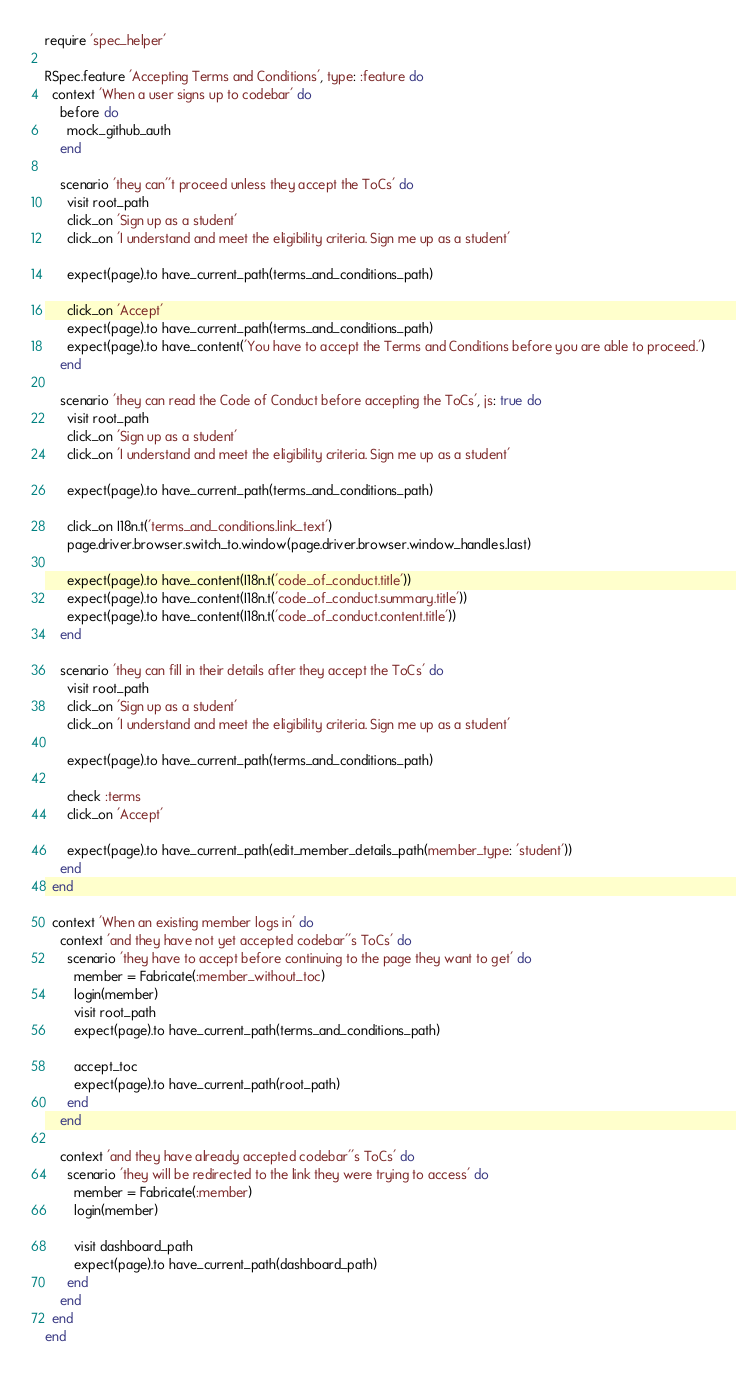Convert code to text. <code><loc_0><loc_0><loc_500><loc_500><_Ruby_>require 'spec_helper'

RSpec.feature 'Accepting Terms and Conditions', type: :feature do
  context 'When a user signs up to codebar' do
    before do
      mock_github_auth
    end

    scenario 'they can''t proceed unless they accept the ToCs' do
      visit root_path
      click_on 'Sign up as a student'
      click_on 'I understand and meet the eligibility criteria. Sign me up as a student'

      expect(page).to have_current_path(terms_and_conditions_path)

      click_on 'Accept'
      expect(page).to have_current_path(terms_and_conditions_path)
      expect(page).to have_content('You have to accept the Terms and Conditions before you are able to proceed.')
    end

    scenario 'they can read the Code of Conduct before accepting the ToCs', js: true do
      visit root_path
      click_on 'Sign up as a student'
      click_on 'I understand and meet the eligibility criteria. Sign me up as a student'

      expect(page).to have_current_path(terms_and_conditions_path)

      click_on I18n.t('terms_and_conditions.link_text')
      page.driver.browser.switch_to.window(page.driver.browser.window_handles.last)

      expect(page).to have_content(I18n.t('code_of_conduct.title'))
      expect(page).to have_content(I18n.t('code_of_conduct.summary.title'))
      expect(page).to have_content(I18n.t('code_of_conduct.content.title'))
    end

    scenario 'they can fill in their details after they accept the ToCs' do
      visit root_path
      click_on 'Sign up as a student'
      click_on 'I understand and meet the eligibility criteria. Sign me up as a student'

      expect(page).to have_current_path(terms_and_conditions_path)

      check :terms
      click_on 'Accept'

      expect(page).to have_current_path(edit_member_details_path(member_type: 'student'))
    end
  end

  context 'When an existing member logs in' do
    context 'and they have not yet accepted codebar''s ToCs' do
      scenario 'they have to accept before continuing to the page they want to get' do
        member = Fabricate(:member_without_toc)
        login(member)
        visit root_path
        expect(page).to have_current_path(terms_and_conditions_path)

        accept_toc
        expect(page).to have_current_path(root_path)
      end
    end

    context 'and they have already accepted codebar''s ToCs' do
      scenario 'they will be redirected to the link they were trying to access' do
        member = Fabricate(:member)
        login(member)

        visit dashboard_path
        expect(page).to have_current_path(dashboard_path)
      end
    end
  end
end
</code> 